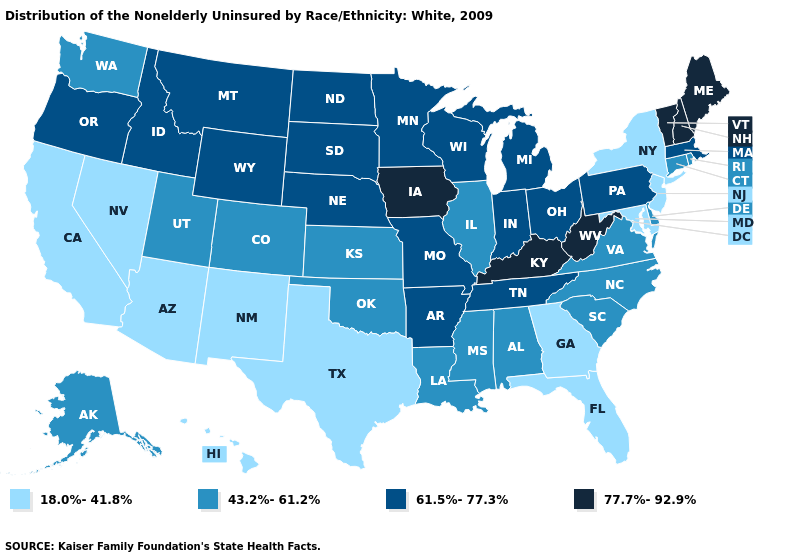Name the states that have a value in the range 43.2%-61.2%?
Answer briefly. Alabama, Alaska, Colorado, Connecticut, Delaware, Illinois, Kansas, Louisiana, Mississippi, North Carolina, Oklahoma, Rhode Island, South Carolina, Utah, Virginia, Washington. Which states have the lowest value in the USA?
Concise answer only. Arizona, California, Florida, Georgia, Hawaii, Maryland, Nevada, New Jersey, New Mexico, New York, Texas. What is the value of Nebraska?
Concise answer only. 61.5%-77.3%. Does Kentucky have the highest value in the USA?
Give a very brief answer. Yes. Name the states that have a value in the range 61.5%-77.3%?
Quick response, please. Arkansas, Idaho, Indiana, Massachusetts, Michigan, Minnesota, Missouri, Montana, Nebraska, North Dakota, Ohio, Oregon, Pennsylvania, South Dakota, Tennessee, Wisconsin, Wyoming. What is the value of Kansas?
Be succinct. 43.2%-61.2%. What is the value of Missouri?
Write a very short answer. 61.5%-77.3%. What is the highest value in the West ?
Keep it brief. 61.5%-77.3%. Does New Hampshire have the highest value in the USA?
Concise answer only. Yes. Name the states that have a value in the range 61.5%-77.3%?
Be succinct. Arkansas, Idaho, Indiana, Massachusetts, Michigan, Minnesota, Missouri, Montana, Nebraska, North Dakota, Ohio, Oregon, Pennsylvania, South Dakota, Tennessee, Wisconsin, Wyoming. Is the legend a continuous bar?
Be succinct. No. Does the map have missing data?
Quick response, please. No. Does the map have missing data?
Write a very short answer. No. Which states have the lowest value in the Northeast?
Be succinct. New Jersey, New York. What is the value of Montana?
Give a very brief answer. 61.5%-77.3%. 